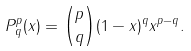Convert formula to latex. <formula><loc_0><loc_0><loc_500><loc_500>P _ { q } ^ { p } ( x ) = \binom { p } { q } ( 1 - x ) ^ { q } x ^ { p - q } .</formula> 